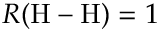<formula> <loc_0><loc_0><loc_500><loc_500>R ( H - H ) = 1</formula> 